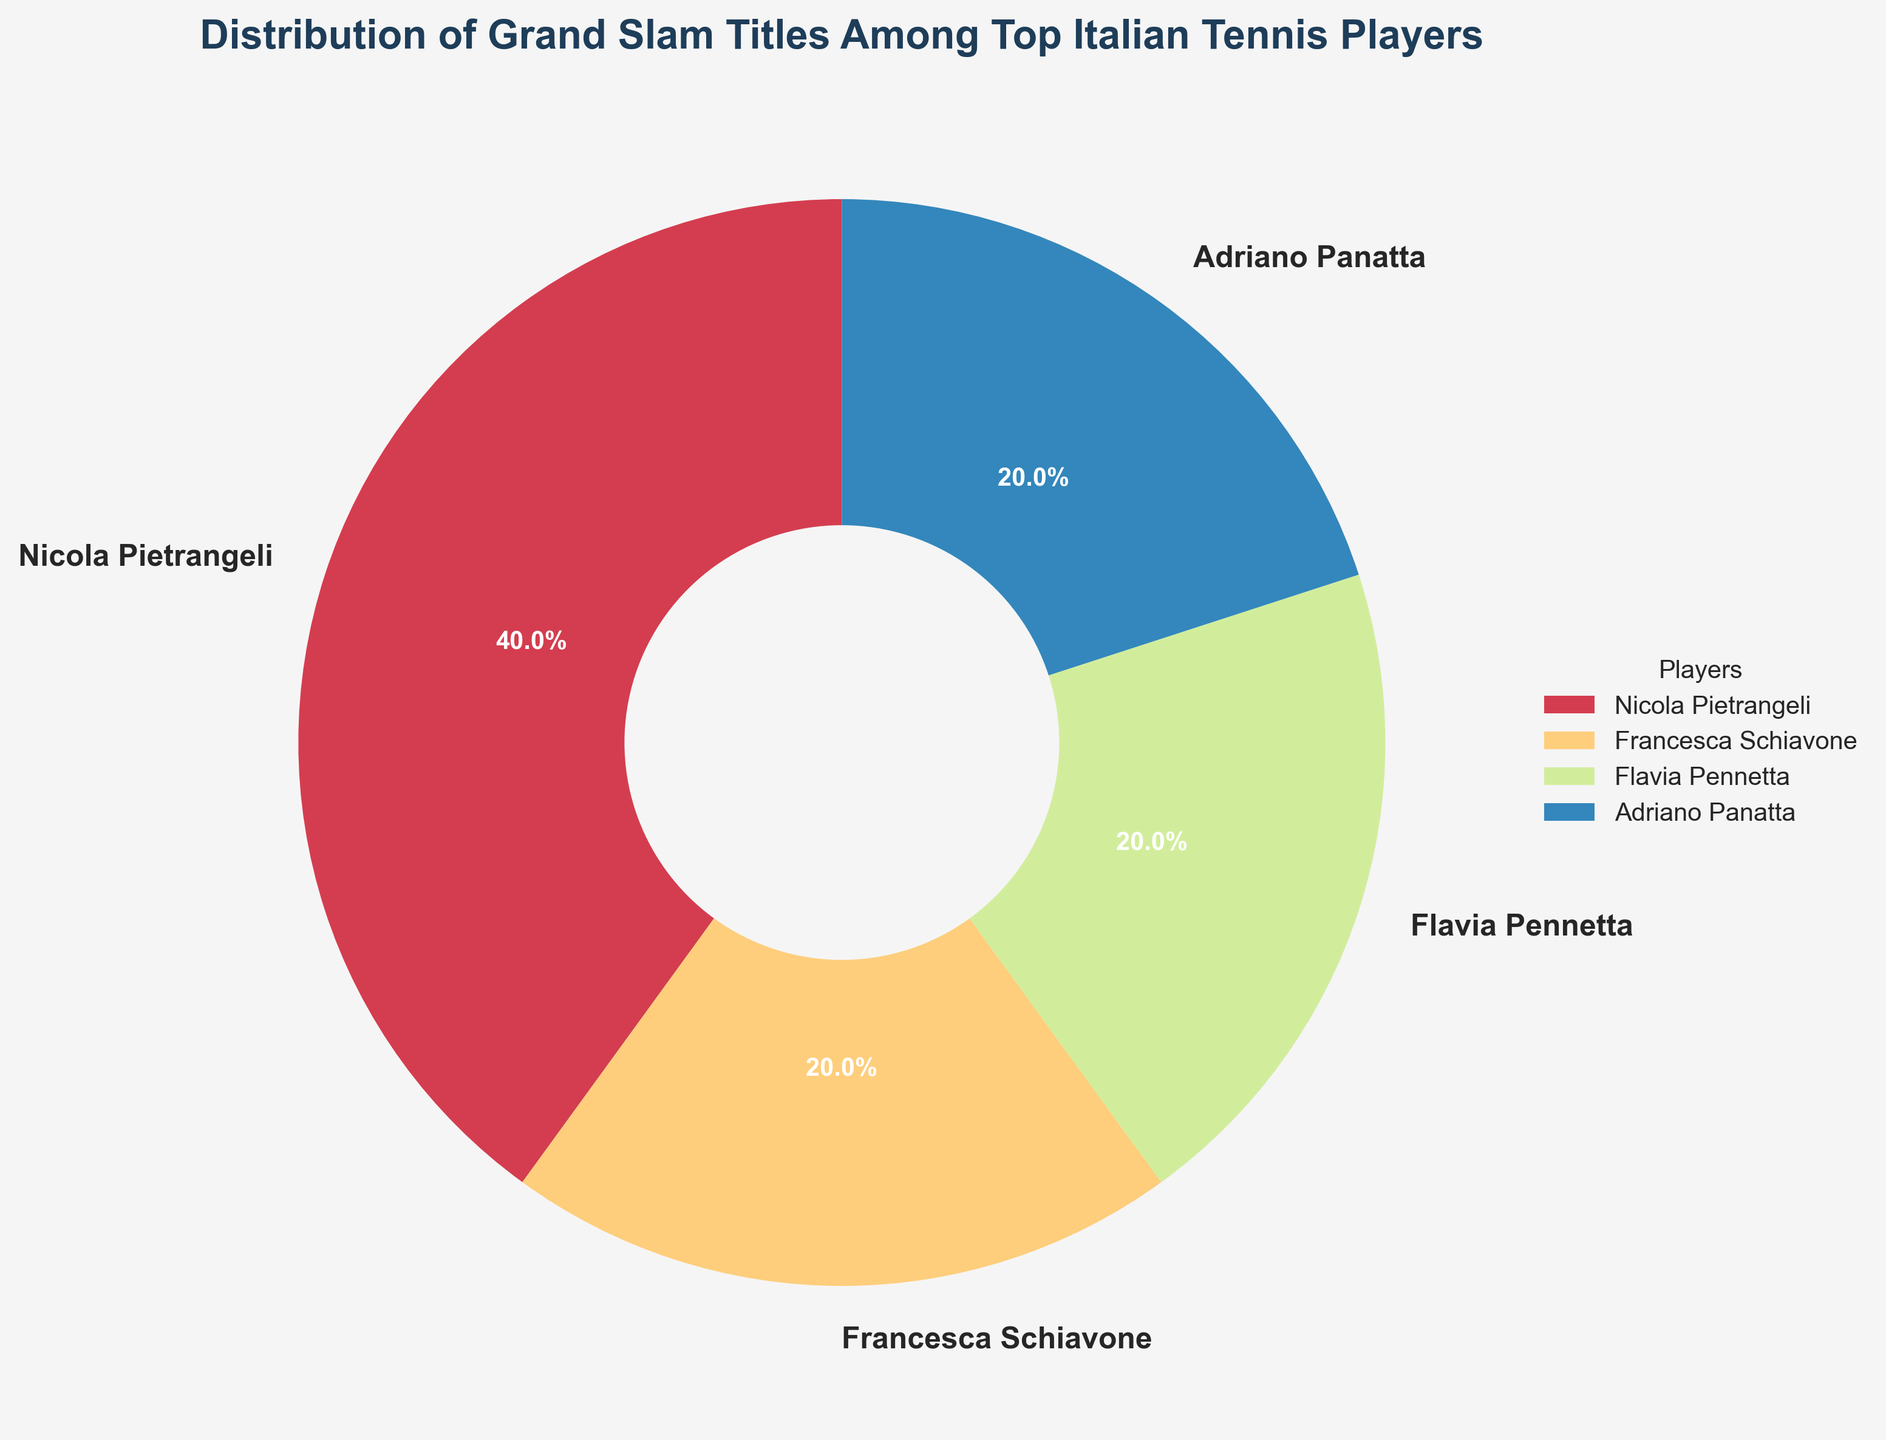What's the total number of Grand Slam titles won by the top Italian tennis players? Sum up all the Grand Slam titles visible in the pie chart: Nicola Pietrangeli (2), Francesca Schiavone (1), Flavia Pennetta (1), and Adriano Panatta (1). So, the total is 2 + 1 + 1 + 1 = 5.
Answer: 5 Who has won the highest percentage of Grand Slam titles among these players? Observe from the pie chart which player occupies the largest segment. Nicola Pietrangeli has the largest segment with 40% of the Grand Slam titles.
Answer: Nicola Pietrangeli What is the combined percentage of Grand Slam titles won by Francesca Schiavone and Flavia Pennetta? According to the pie chart, Francesca Schiavone has 20% and Flavia Pennetta also has 20%. The combined percentage is 20% + 20% = 40%.
Answer: 40% How many players have won at least one Grand Slam title? Count the number of segments in the pie chart. Each segment represents a player who has won at least one Grand Slam title. There are 4 segments: Nicola Pietrangeli, Francesca Schiavone, Flavia Pennetta, and Adriano Panatta.
Answer: 4 What is the difference in the number of Grand Slam titles between Nicola Pietrangeli and Adriano Panatta? According to the pie chart, Nicola Pietrangeli has won 2 Grand Slam titles, while Adriano Panatta has won 1. The difference is 2 - 1 = 1.
Answer: 1 Who are the players who have each won exactly 20% of the Grand Slam titles? Identify from the pie chart which players' segments are labeled with 20%. Francesca Schiavone and Flavia Pennetta each have 20%.
Answer: Francesca Schiavone, Flavia Pennetta Which color represents Nicola Pietrangeli's Grand Slam titles in the pie chart? By looking at the pie chart, identify the color of the largest segment, which represents Nicola Pietrangeli's titles. Nicola Pietrangeli's segment is typically shown with a prominent color.
Answer: Varies (could be verified from the chart) List the players in descending order based on their Grand Slam titles count. Using the pie chart's relative sizes and labels, order the players: Nicola Pietrangeli (2), Francesca Schiavone (1), Flavia Pennetta (1), and Adriano Panatta (1).
Answer: Nicola Pietrangeli, Francesca Schiavone, Flavia Pennetta, Adriano Panatta What fraction of the total Grand Slam titles did Flavia Pennetta win? Flavia Pennetta won 1 title out of a total of 5 titles. The fraction is 1/5.
Answer: 1/5 